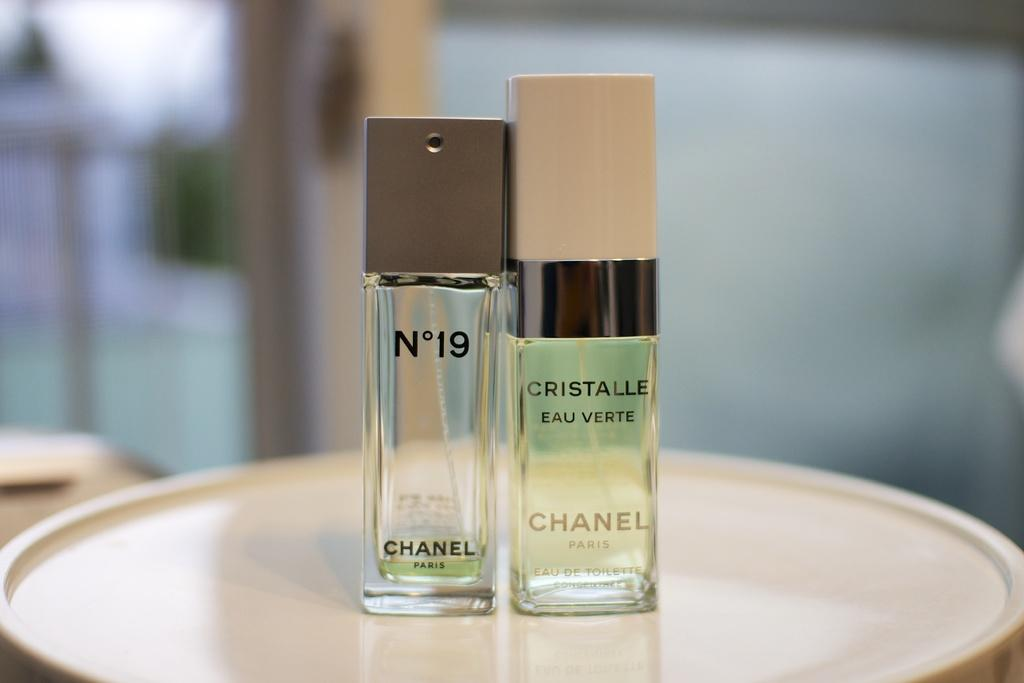<image>
Offer a succinct explanation of the picture presented. Two beauty products made by Chanel stand side by side. 